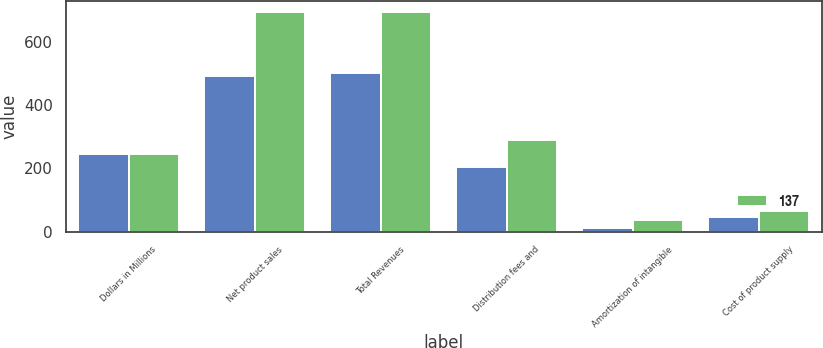Convert chart to OTSL. <chart><loc_0><loc_0><loc_500><loc_500><stacked_bar_chart><ecel><fcel>Dollars in Millions<fcel>Net product sales<fcel>Total Revenues<fcel>Distribution fees and<fcel>Amortization of intangible<fcel>Cost of product supply<nl><fcel>nan<fcel>246.5<fcel>492<fcel>501<fcel>204<fcel>11<fcel>46<nl><fcel>137<fcel>246.5<fcel>696<fcel>696<fcel>289<fcel>37<fcel>65<nl></chart> 